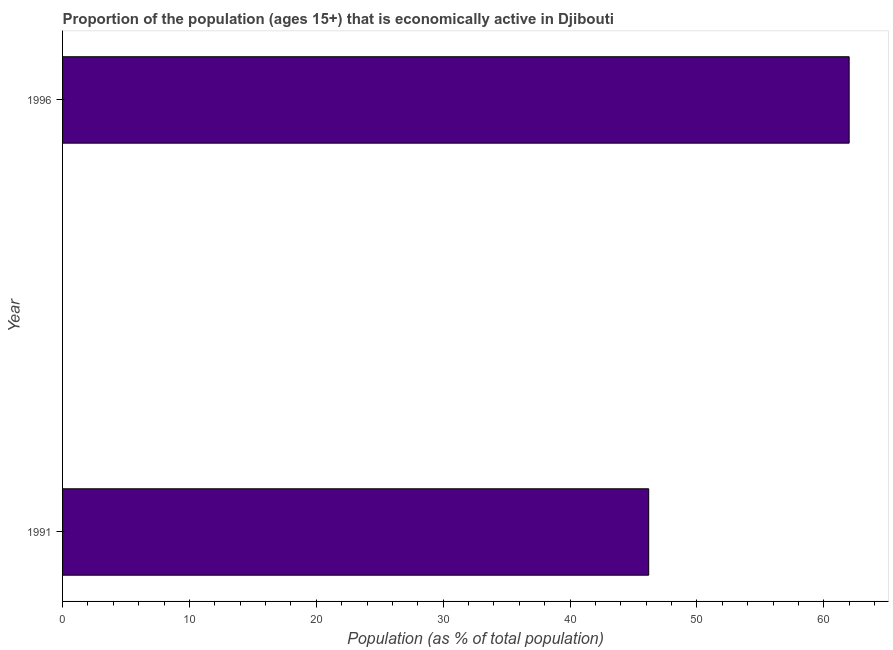Does the graph contain any zero values?
Make the answer very short. No. What is the title of the graph?
Provide a short and direct response. Proportion of the population (ages 15+) that is economically active in Djibouti. What is the label or title of the X-axis?
Offer a very short reply. Population (as % of total population). What is the percentage of economically active population in 1996?
Provide a short and direct response. 62. Across all years, what is the minimum percentage of economically active population?
Keep it short and to the point. 46.2. In which year was the percentage of economically active population minimum?
Your answer should be compact. 1991. What is the sum of the percentage of economically active population?
Provide a short and direct response. 108.2. What is the difference between the percentage of economically active population in 1991 and 1996?
Provide a short and direct response. -15.8. What is the average percentage of economically active population per year?
Offer a very short reply. 54.1. What is the median percentage of economically active population?
Ensure brevity in your answer.  54.1. In how many years, is the percentage of economically active population greater than 50 %?
Your answer should be compact. 1. Do a majority of the years between 1991 and 1996 (inclusive) have percentage of economically active population greater than 6 %?
Your response must be concise. Yes. What is the ratio of the percentage of economically active population in 1991 to that in 1996?
Your answer should be very brief. 0.74. Is the percentage of economically active population in 1991 less than that in 1996?
Your response must be concise. Yes. How many bars are there?
Offer a terse response. 2. How many years are there in the graph?
Keep it short and to the point. 2. What is the difference between two consecutive major ticks on the X-axis?
Keep it short and to the point. 10. What is the Population (as % of total population) in 1991?
Ensure brevity in your answer.  46.2. What is the difference between the Population (as % of total population) in 1991 and 1996?
Ensure brevity in your answer.  -15.8. What is the ratio of the Population (as % of total population) in 1991 to that in 1996?
Your answer should be very brief. 0.74. 